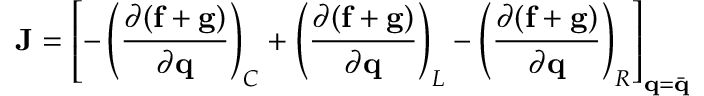<formula> <loc_0><loc_0><loc_500><loc_500>J = \left [ - \left ( \frac { \partial ( f + g ) } { \partial q } \right ) _ { C } + \left ( \frac { \partial ( f + g ) } { \partial q } \right ) _ { L } - \left ( \frac { \partial ( f + g ) } { \partial q } \right ) _ { R } \right ] _ { q = \ B a r { q } }</formula> 